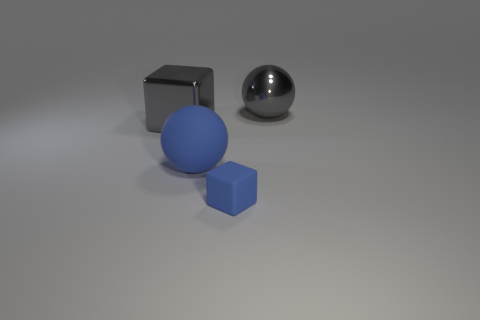Add 3 yellow shiny objects. How many objects exist? 7 Subtract all blue spheres. How many spheres are left? 1 Subtract all large gray blocks. Subtract all large spheres. How many objects are left? 1 Add 4 big gray things. How many big gray things are left? 6 Add 4 small cyan matte balls. How many small cyan matte balls exist? 4 Subtract 1 gray balls. How many objects are left? 3 Subtract 1 blocks. How many blocks are left? 1 Subtract all blue cubes. Subtract all cyan cylinders. How many cubes are left? 1 